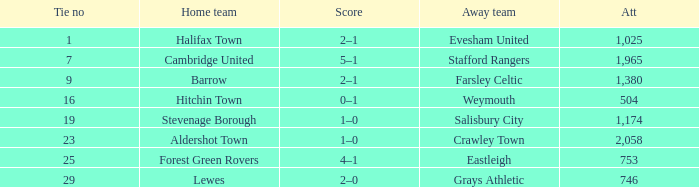How many attended tie number 19? 1174.0. 